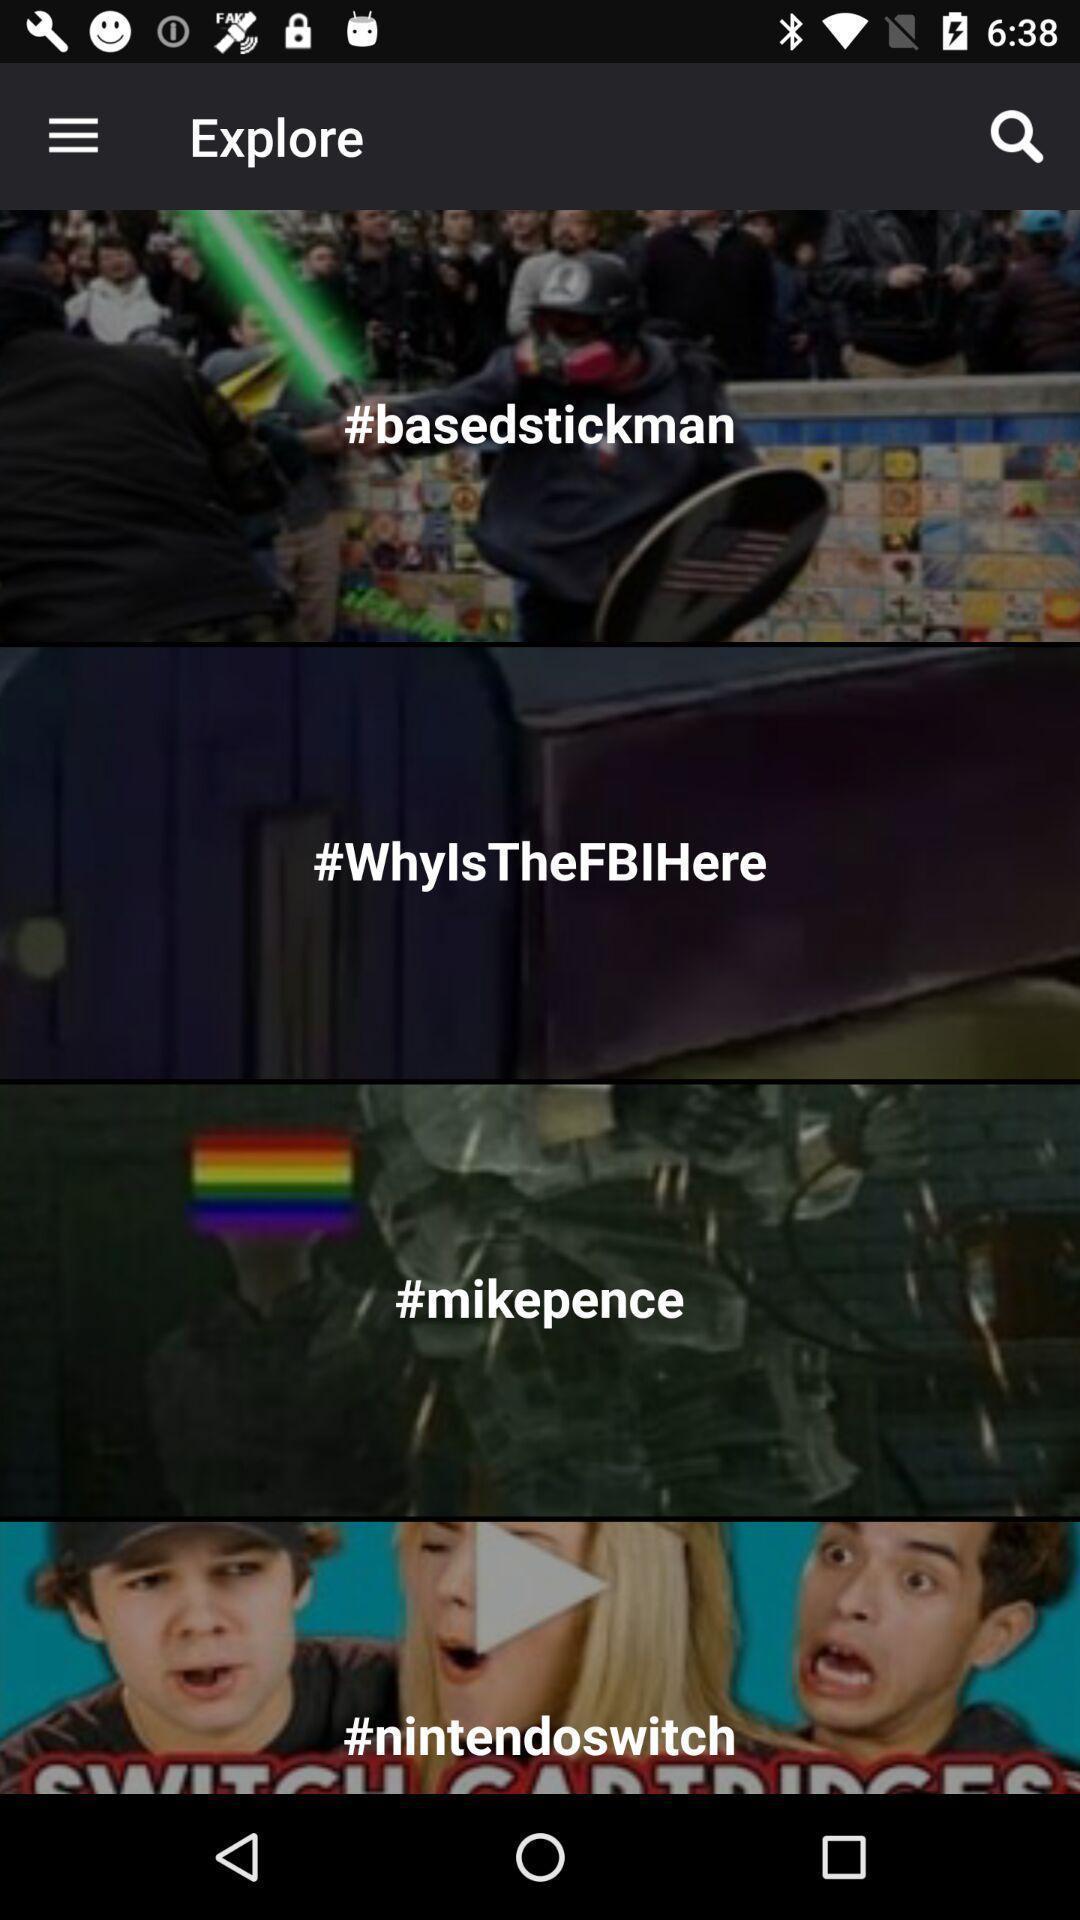Explain what's happening in this screen capture. Screen shows about exploring news. 